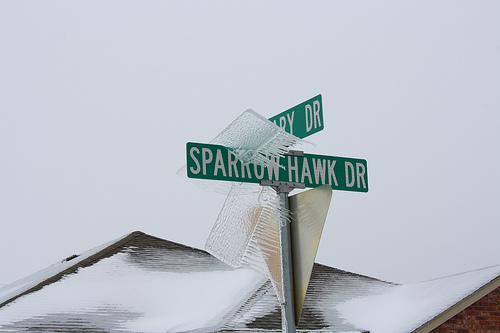Question: how many street signs are in the photo?
Choices:
A. Three.
B. Two.
C. Four.
D. None.
Answer with the letter. Answer: B 